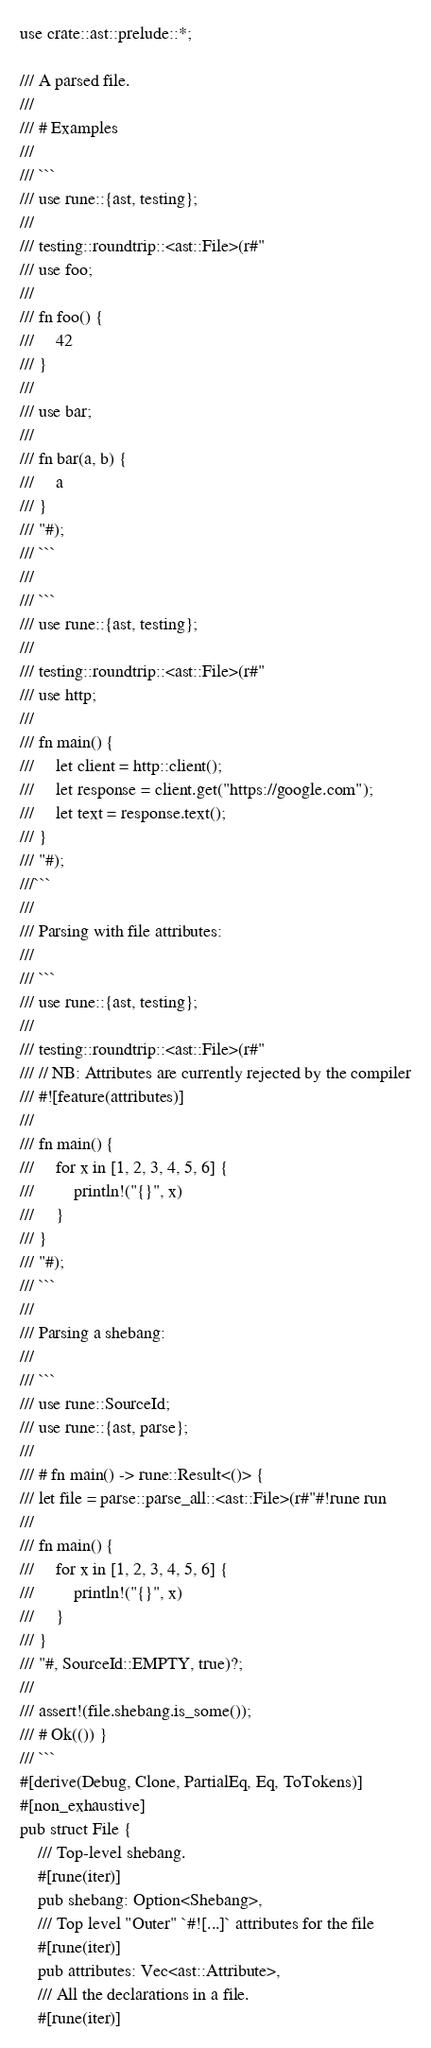<code> <loc_0><loc_0><loc_500><loc_500><_Rust_>use crate::ast::prelude::*;

/// A parsed file.
///
/// # Examples
///
/// ```
/// use rune::{ast, testing};
///
/// testing::roundtrip::<ast::File>(r#"
/// use foo;
///
/// fn foo() {
///     42
/// }
///
/// use bar;
///
/// fn bar(a, b) {
///     a
/// }
/// "#);
/// ```
///
/// ```
/// use rune::{ast, testing};
///
/// testing::roundtrip::<ast::File>(r#"
/// use http;
///
/// fn main() {
///     let client = http::client();
///     let response = client.get("https://google.com");
///     let text = response.text();
/// }
/// "#);
///```
///
/// Parsing with file attributes:
///
/// ```
/// use rune::{ast, testing};
///
/// testing::roundtrip::<ast::File>(r#"
/// // NB: Attributes are currently rejected by the compiler
/// #![feature(attributes)]
///
/// fn main() {
///     for x in [1, 2, 3, 4, 5, 6] {
///         println!("{}", x)
///     }
/// }
/// "#);
/// ```
///
/// Parsing a shebang:
///
/// ```
/// use rune::SourceId;
/// use rune::{ast, parse};
///
/// # fn main() -> rune::Result<()> {
/// let file = parse::parse_all::<ast::File>(r#"#!rune run
///
/// fn main() {
///     for x in [1, 2, 3, 4, 5, 6] {
///         println!("{}", x)
///     }
/// }
/// "#, SourceId::EMPTY, true)?;
///
/// assert!(file.shebang.is_some());
/// # Ok(()) }
/// ```
#[derive(Debug, Clone, PartialEq, Eq, ToTokens)]
#[non_exhaustive]
pub struct File {
    /// Top-level shebang.
    #[rune(iter)]
    pub shebang: Option<Shebang>,
    /// Top level "Outer" `#![...]` attributes for the file
    #[rune(iter)]
    pub attributes: Vec<ast::Attribute>,
    /// All the declarations in a file.
    #[rune(iter)]</code> 